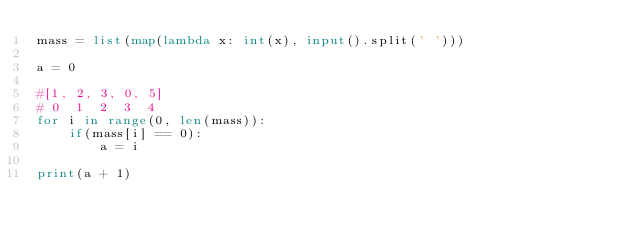<code> <loc_0><loc_0><loc_500><loc_500><_Python_>mass = list(map(lambda x: int(x), input().split(' ')))

a = 0

#[1, 2, 3, 0, 5]
# 0  1  2  3  4
for i in range(0, len(mass)):
    if(mass[i] == 0):
        a = i

print(a + 1)</code> 